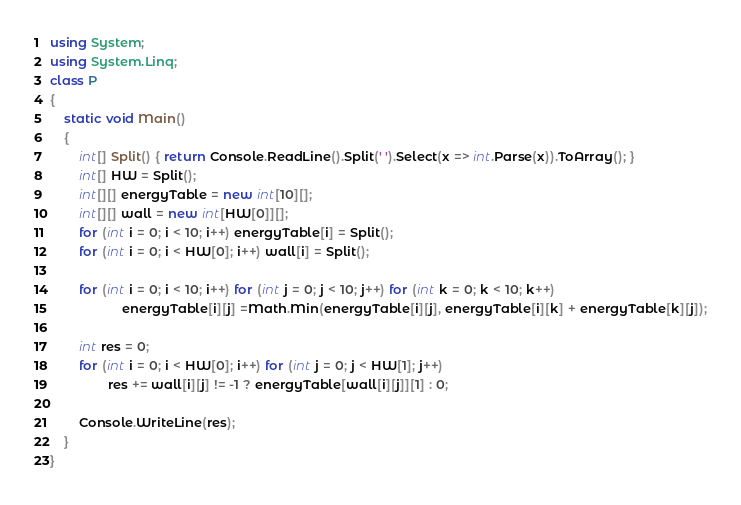<code> <loc_0><loc_0><loc_500><loc_500><_C#_>using System;
using System.Linq;
class P
{
    static void Main()
    {
        int[] Split() { return Console.ReadLine().Split(' ').Select(x => int.Parse(x)).ToArray(); }
        int[] HW = Split();
        int[][] energyTable = new int[10][];
        int[][] wall = new int[HW[0]][];
        for (int i = 0; i < 10; i++) energyTable[i] = Split();
        for (int i = 0; i < HW[0]; i++) wall[i] = Split();
        
        for (int i = 0; i < 10; i++) for (int j = 0; j < 10; j++) for (int k = 0; k < 10; k++)
                    energyTable[i][j] =Math.Min(energyTable[i][j], energyTable[i][k] + energyTable[k][j]);

        int res = 0;
        for (int i = 0; i < HW[0]; i++) for (int j = 0; j < HW[1]; j++)
                res += wall[i][j] != -1 ? energyTable[wall[i][j]][1] : 0;
        
        Console.WriteLine(res);
    }
}</code> 